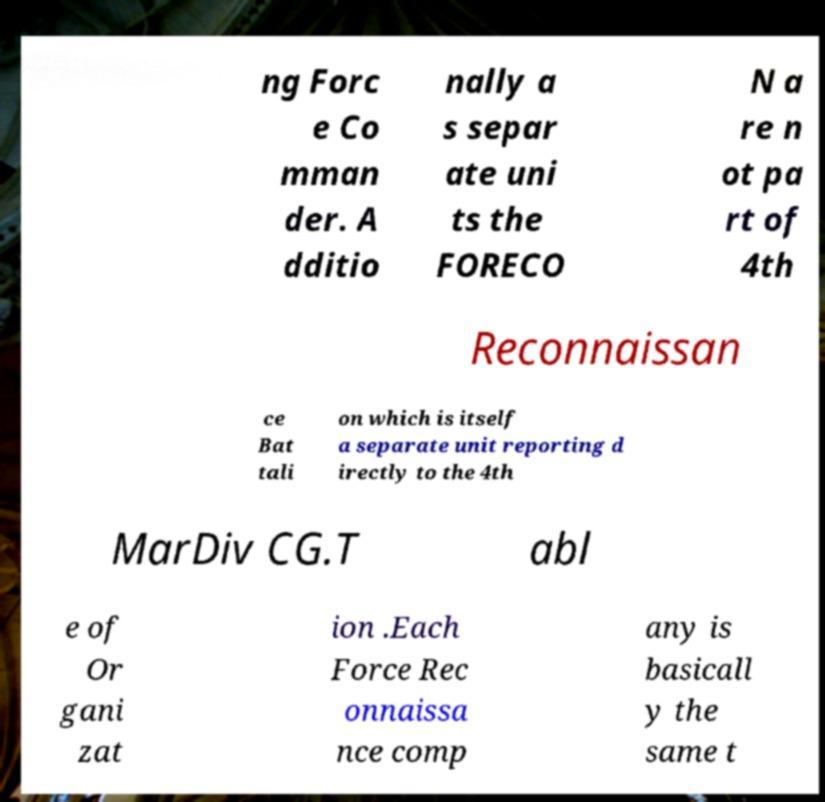I need the written content from this picture converted into text. Can you do that? ng Forc e Co mman der. A dditio nally a s separ ate uni ts the FORECO N a re n ot pa rt of 4th Reconnaissan ce Bat tali on which is itself a separate unit reporting d irectly to the 4th MarDiv CG.T abl e of Or gani zat ion .Each Force Rec onnaissa nce comp any is basicall y the same t 